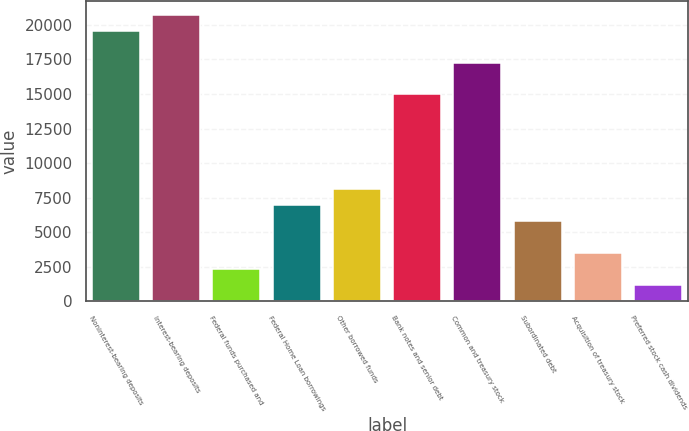Convert chart. <chart><loc_0><loc_0><loc_500><loc_500><bar_chart><fcel>Noninterest-bearing deposits<fcel>Interest-bearing deposits<fcel>Federal funds purchased and<fcel>Federal Home Loan borrowings<fcel>Other borrowed funds<fcel>Bank notes and senior debt<fcel>Common and treasury stock<fcel>Subordinated debt<fcel>Acquisition of treasury stock<fcel>Preferred stock cash dividends<nl><fcel>19566.6<fcel>20714.4<fcel>2349.6<fcel>6940.8<fcel>8088.6<fcel>14975.4<fcel>17271<fcel>5793<fcel>3497.4<fcel>1201.8<nl></chart> 